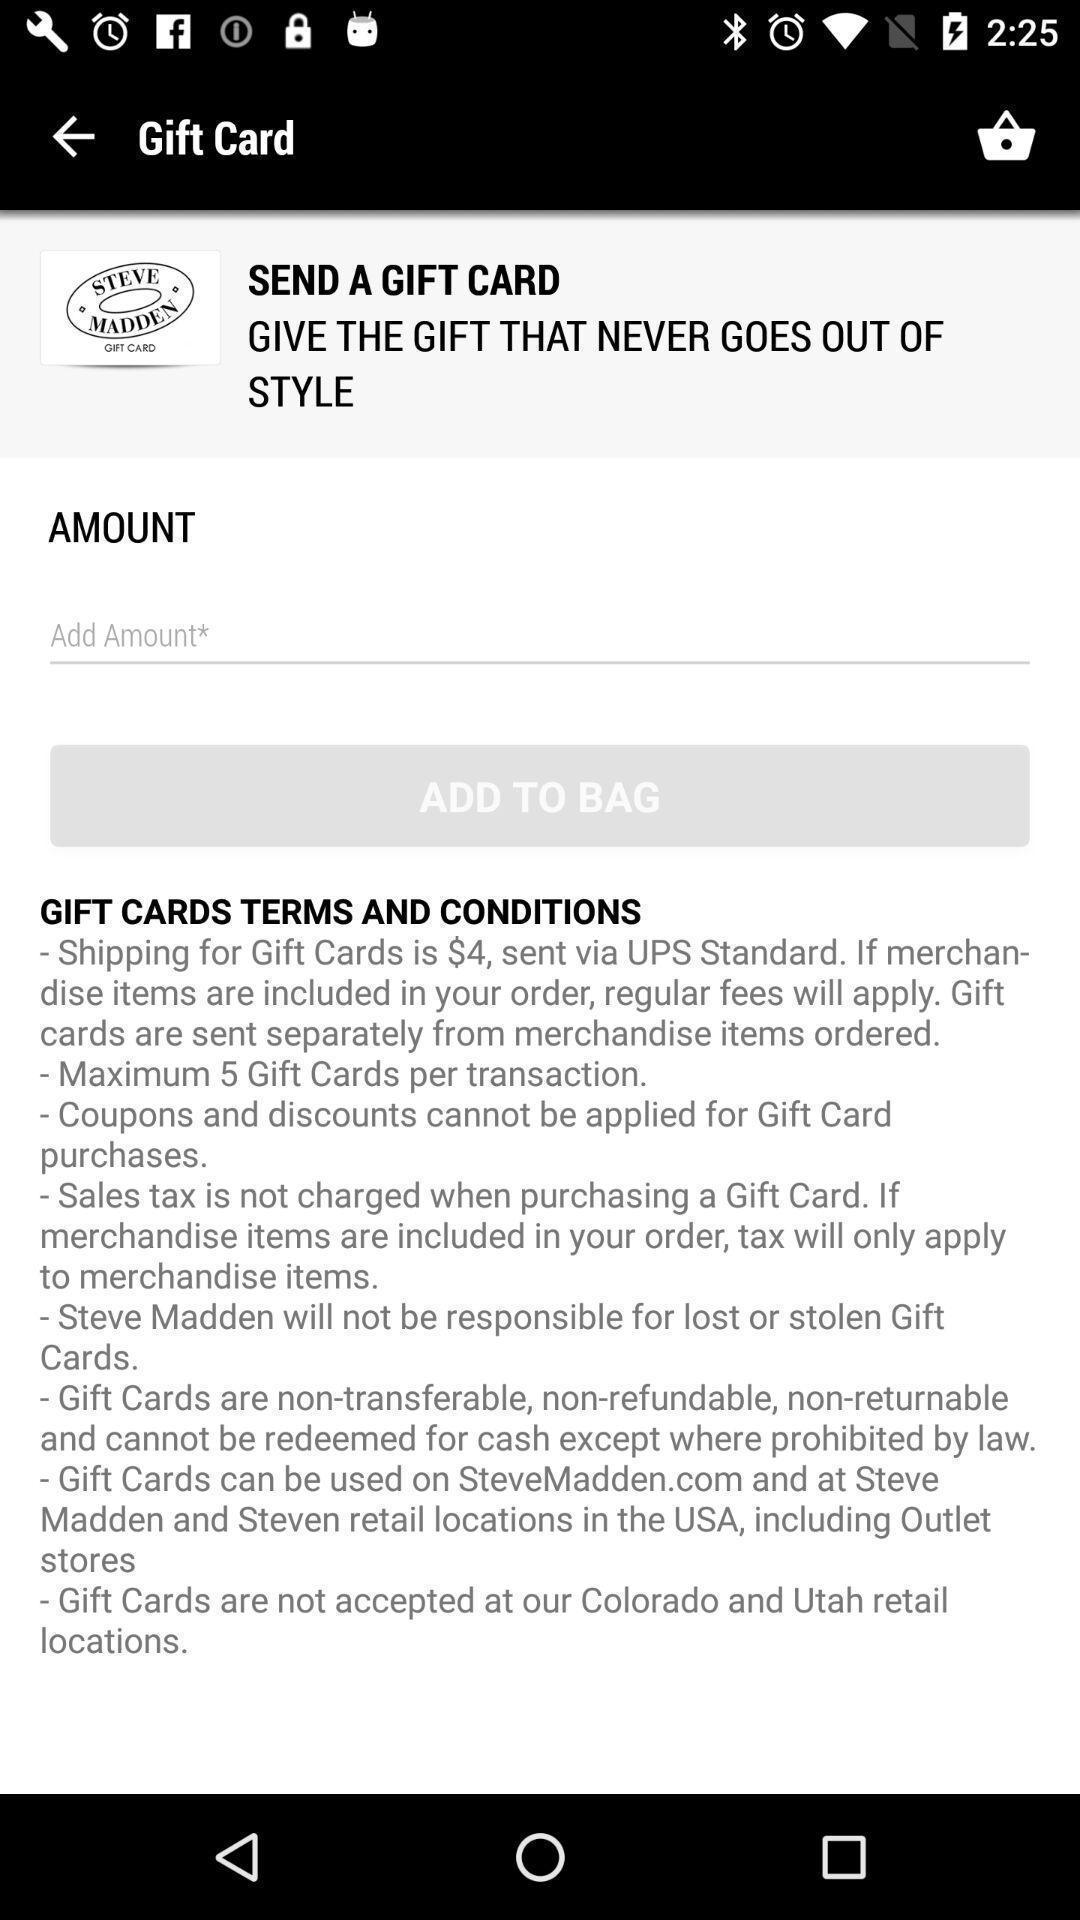Give me a narrative description of this picture. Payment page to book an item in a shopping app. 